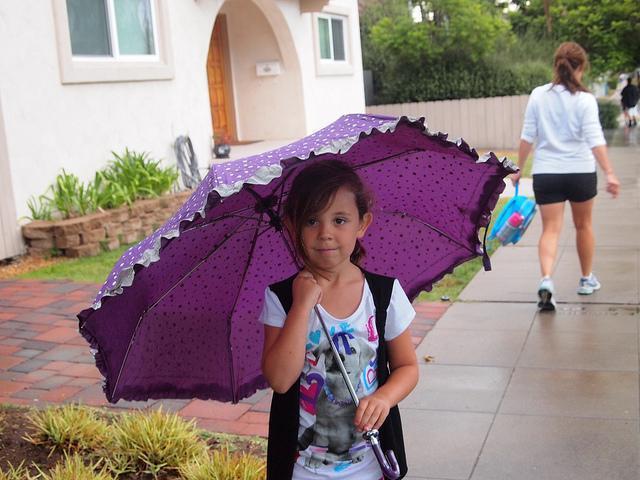How many potted plants can be seen?
Give a very brief answer. 1. How many people are there?
Give a very brief answer. 2. How many umbrellas are there?
Give a very brief answer. 1. How many little elephants are in the image?
Give a very brief answer. 0. 